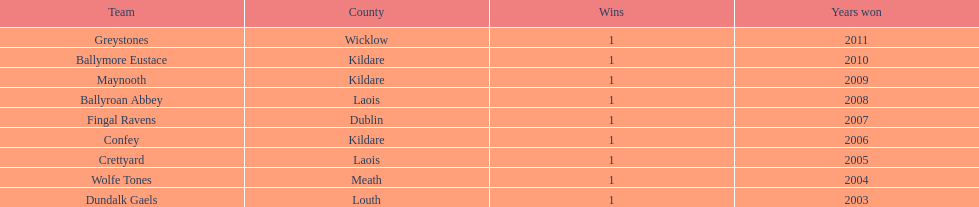Can you parse all the data within this table? {'header': ['Team', 'County', 'Wins', 'Years won'], 'rows': [['Greystones', 'Wicklow', '1', '2011'], ['Ballymore Eustace', 'Kildare', '1', '2010'], ['Maynooth', 'Kildare', '1', '2009'], ['Ballyroan Abbey', 'Laois', '1', '2008'], ['Fingal Ravens', 'Dublin', '1', '2007'], ['Confey', 'Kildare', '1', '2006'], ['Crettyard', 'Laois', '1', '2005'], ['Wolfe Tones', 'Meath', '1', '2004'], ['Dundalk Gaels', 'Louth', '1', '2003']]} How many wins does greystones have? 1. 